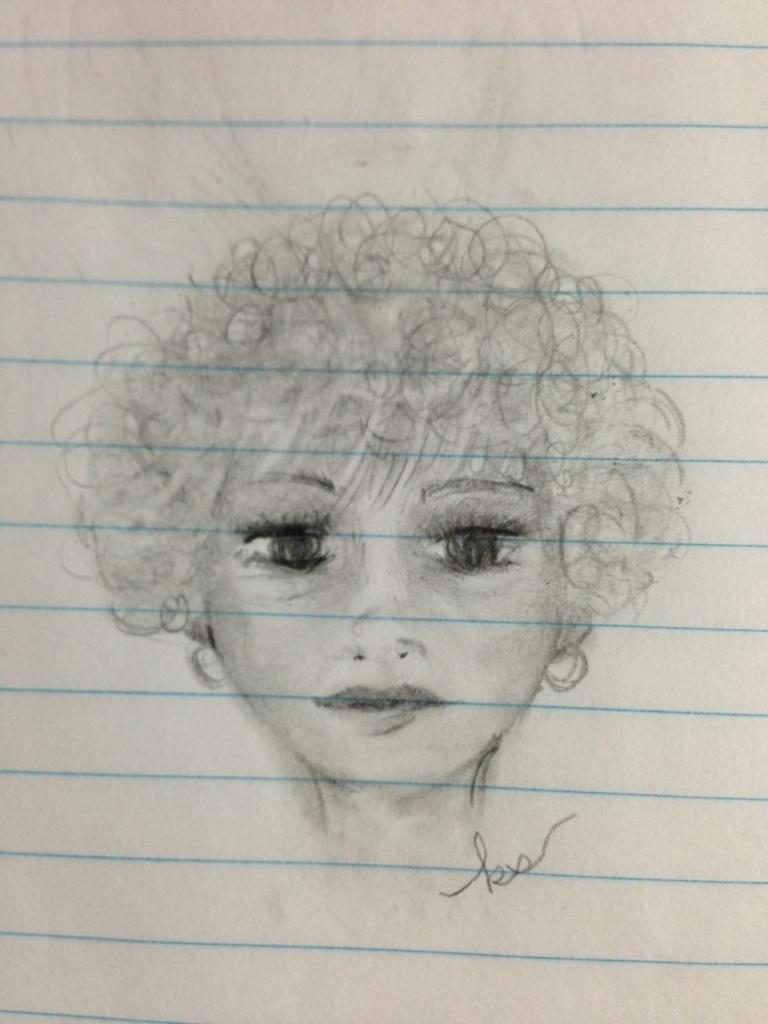In one or two sentences, can you explain what this image depicts? In this image we can see the sketch of the person on the paper. 